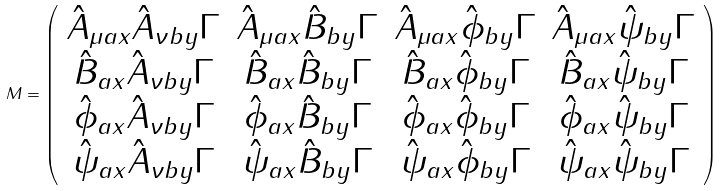<formula> <loc_0><loc_0><loc_500><loc_500>M = \left ( \begin{array} { c c c c } \hat { A } _ { \mu a x } \hat { A } _ { \nu b y } \Gamma & \hat { A } _ { \mu a x } \hat { B } _ { b y } \Gamma & \hat { A } _ { \mu a x } \hat { \phi } _ { b y } \Gamma & \hat { A } _ { \mu a x } \hat { \psi } _ { b y } \Gamma \\ \hat { B } _ { a x } \hat { A } _ { \nu b y } \Gamma & \hat { B } _ { a x } \hat { B } _ { b y } \Gamma & \hat { B } _ { a x } \hat { \phi } _ { b y } \Gamma & \hat { B } _ { a x } \hat { \psi } _ { b y } \Gamma \\ \hat { \phi } _ { a x } \hat { A } _ { \nu b y } \Gamma & \hat { \phi } _ { a x } \hat { B } _ { b y } \Gamma & \hat { \phi } _ { a x } \hat { \phi } _ { b y } \Gamma & \hat { \phi } _ { a x } \hat { \psi } _ { b y } \Gamma \\ \hat { \psi } _ { a x } \hat { A } _ { \nu b y } \Gamma & \hat { \psi } _ { a x } \hat { B } _ { b y } \Gamma & \hat { \psi } _ { a x } \hat { \phi } _ { b y } \Gamma & \hat { \psi } _ { a x } \hat { \psi } _ { b y } \Gamma \end{array} \right )</formula> 